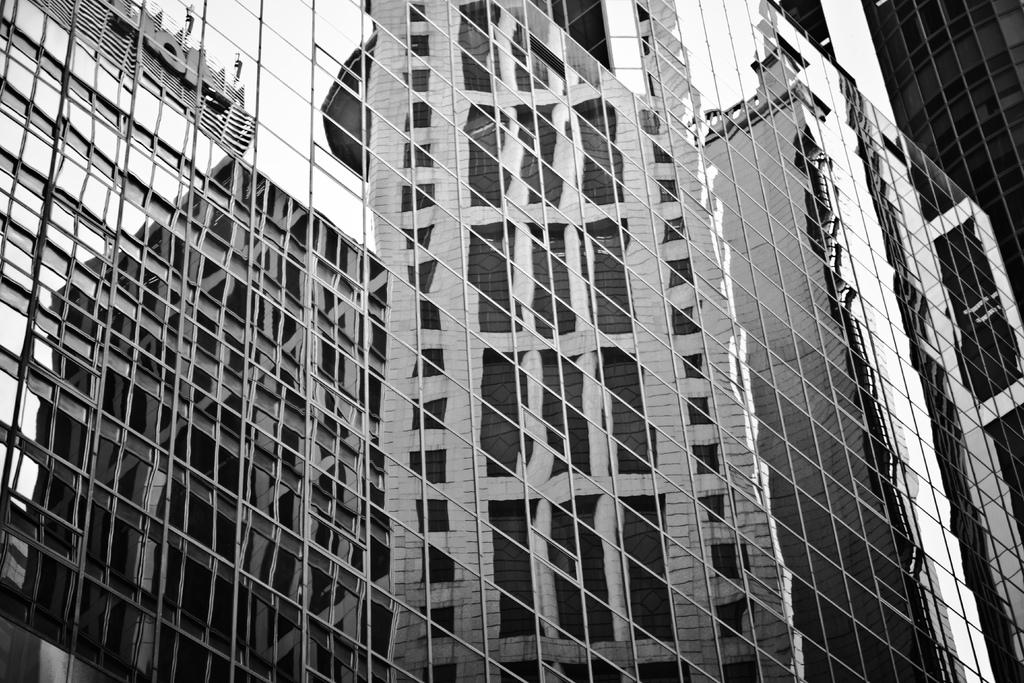What structures are visible in the image? There are buildings in the image. What type of windows do the buildings have? The buildings have glass windows. Where is the seat located in the image? There is no seat present in the image. What type of kite can be seen flying near the buildings in the image? There is no kite present in the image. 